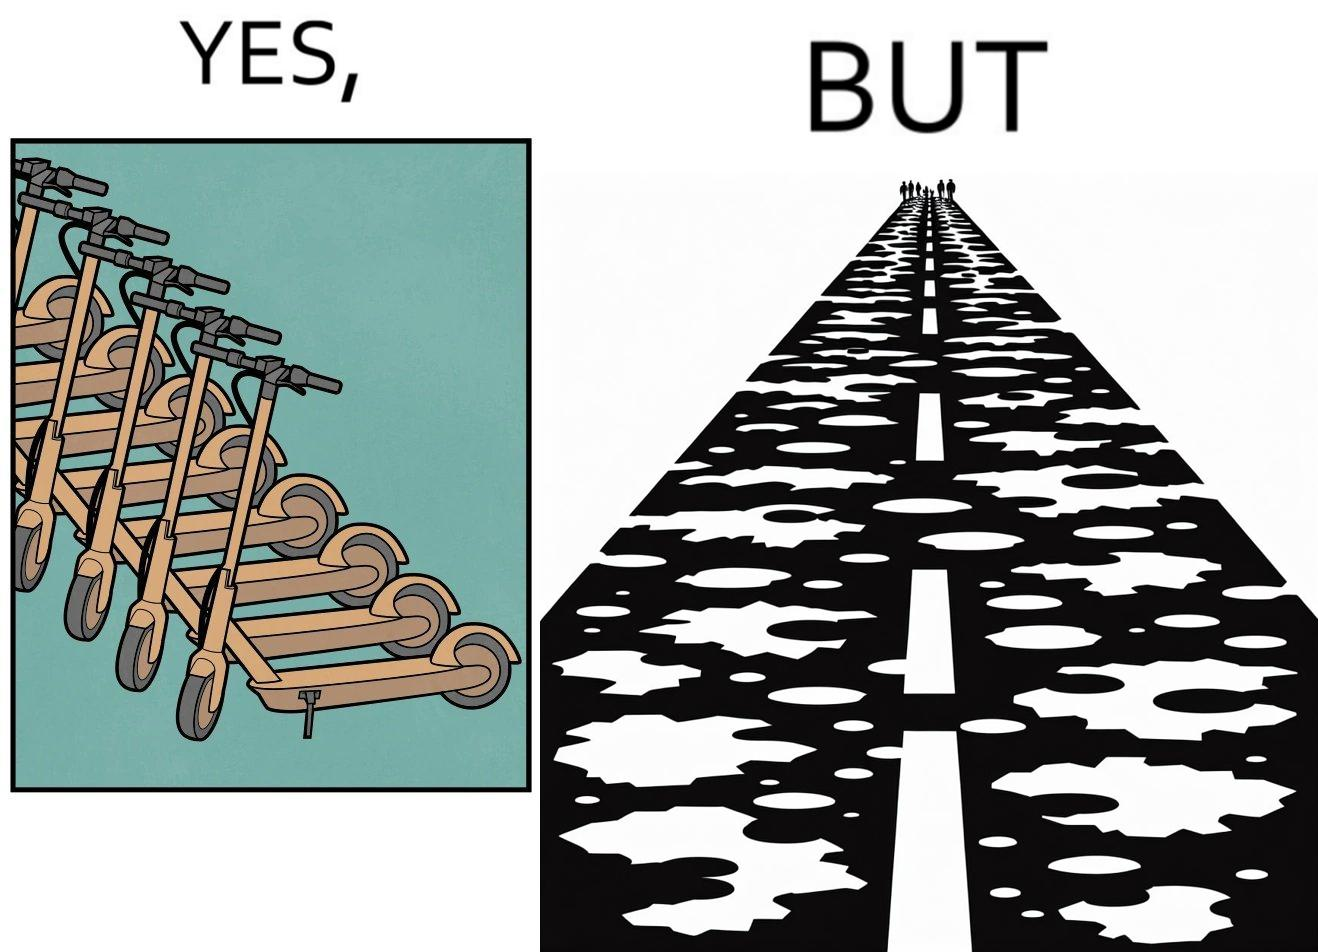Is there satirical content in this image? Yes, this image is satirical. 